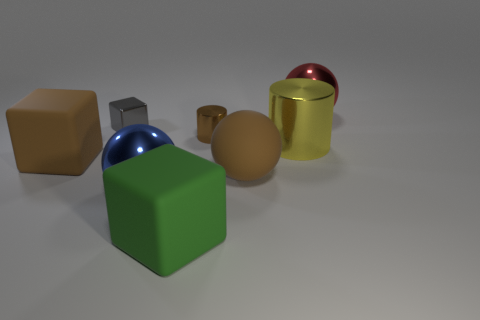Add 1 tiny cubes. How many objects exist? 9 Subtract all cylinders. How many objects are left? 6 Subtract all red metal balls. Subtract all green rubber objects. How many objects are left? 6 Add 6 yellow things. How many yellow things are left? 7 Add 8 big red metal objects. How many big red metal objects exist? 9 Subtract 0 gray balls. How many objects are left? 8 